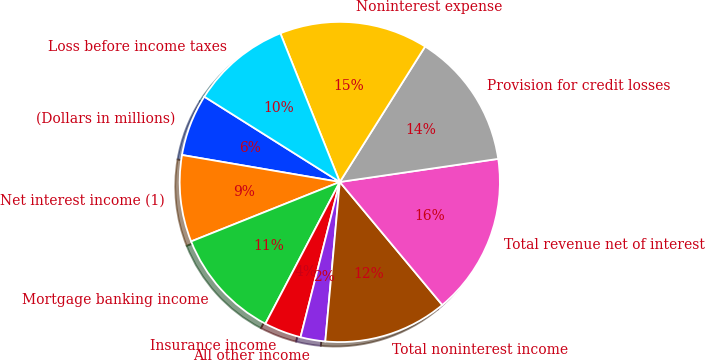Convert chart to OTSL. <chart><loc_0><loc_0><loc_500><loc_500><pie_chart><fcel>(Dollars in millions)<fcel>Net interest income (1)<fcel>Mortgage banking income<fcel>Insurance income<fcel>All other income<fcel>Total noninterest income<fcel>Total revenue net of interest<fcel>Provision for credit losses<fcel>Noninterest expense<fcel>Loss before income taxes<nl><fcel>6.25%<fcel>8.75%<fcel>11.25%<fcel>3.75%<fcel>2.5%<fcel>12.5%<fcel>16.25%<fcel>13.75%<fcel>15.0%<fcel>10.0%<nl></chart> 